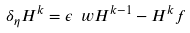<formula> <loc_0><loc_0><loc_500><loc_500>\delta _ { \eta } H ^ { k } = \epsilon \ w H ^ { k - 1 } - H ^ { k } f</formula> 